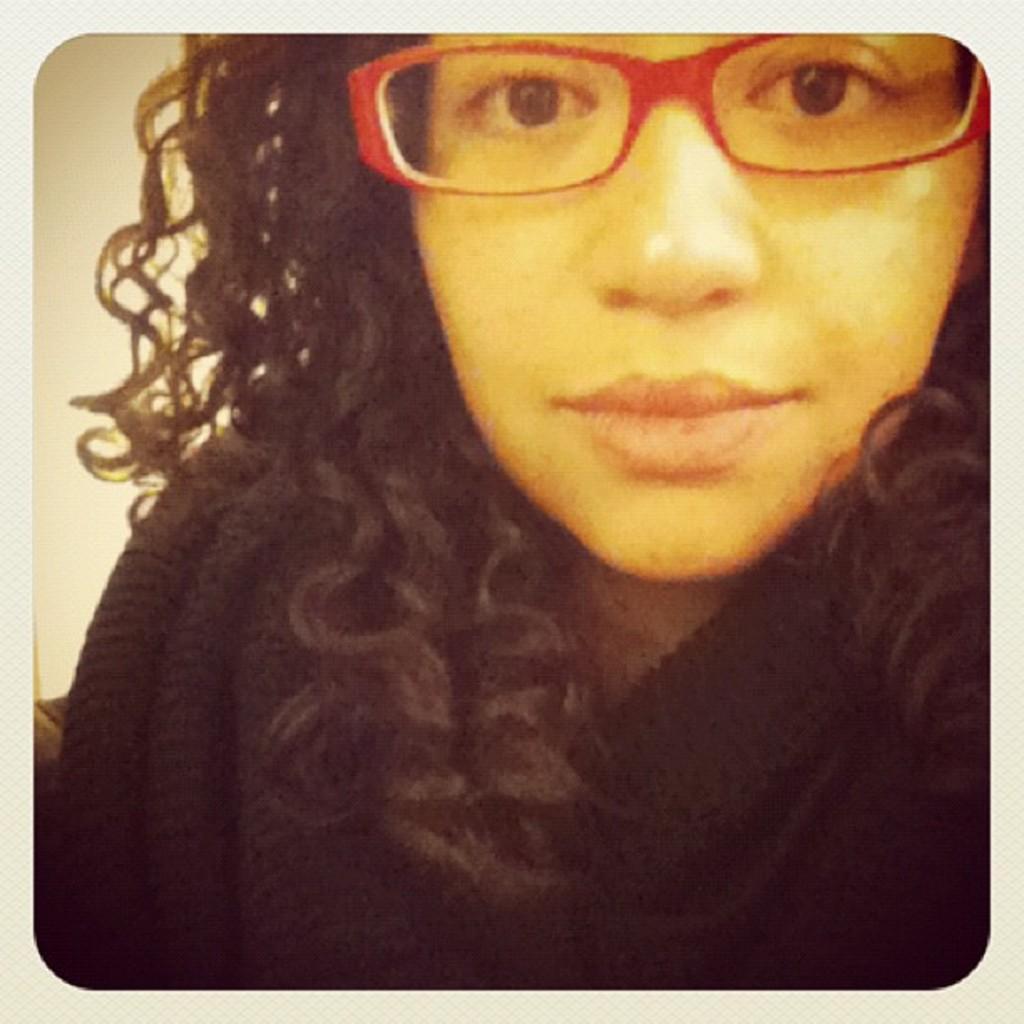Please provide a concise description of this image. In this image, we can see a woman wearing specs. We can see the wall. 